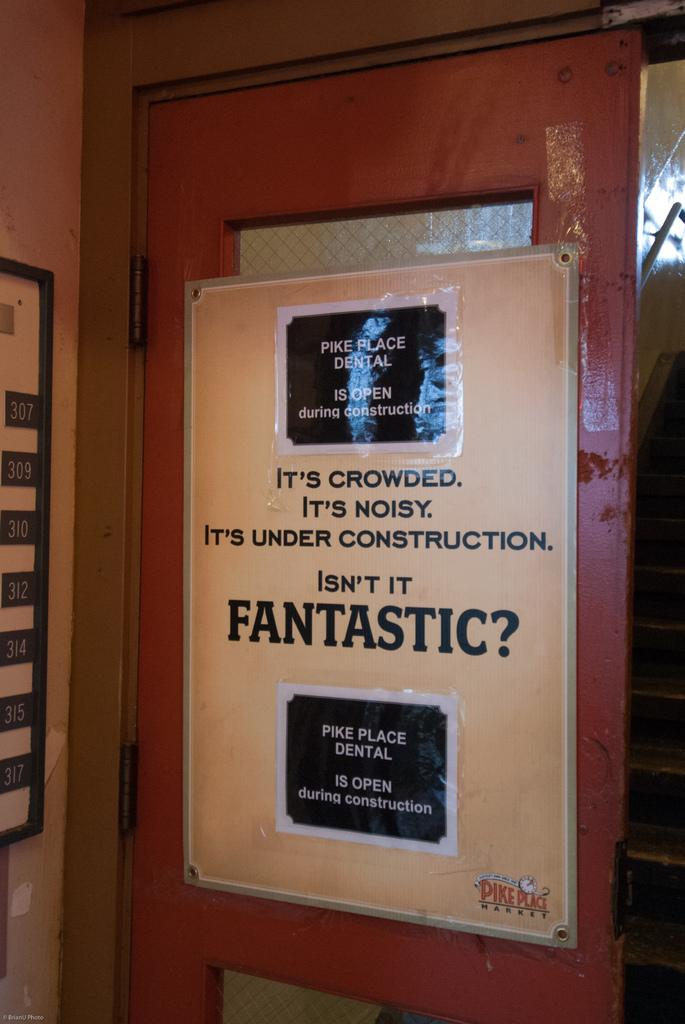What is the main object in the image? There is a board in the image. What is on the board? Posters are attached to the board. Where is the board located? The board is on a wall. What type of tub can be seen on the board in the image? There is no tub present on the board or in the image. 